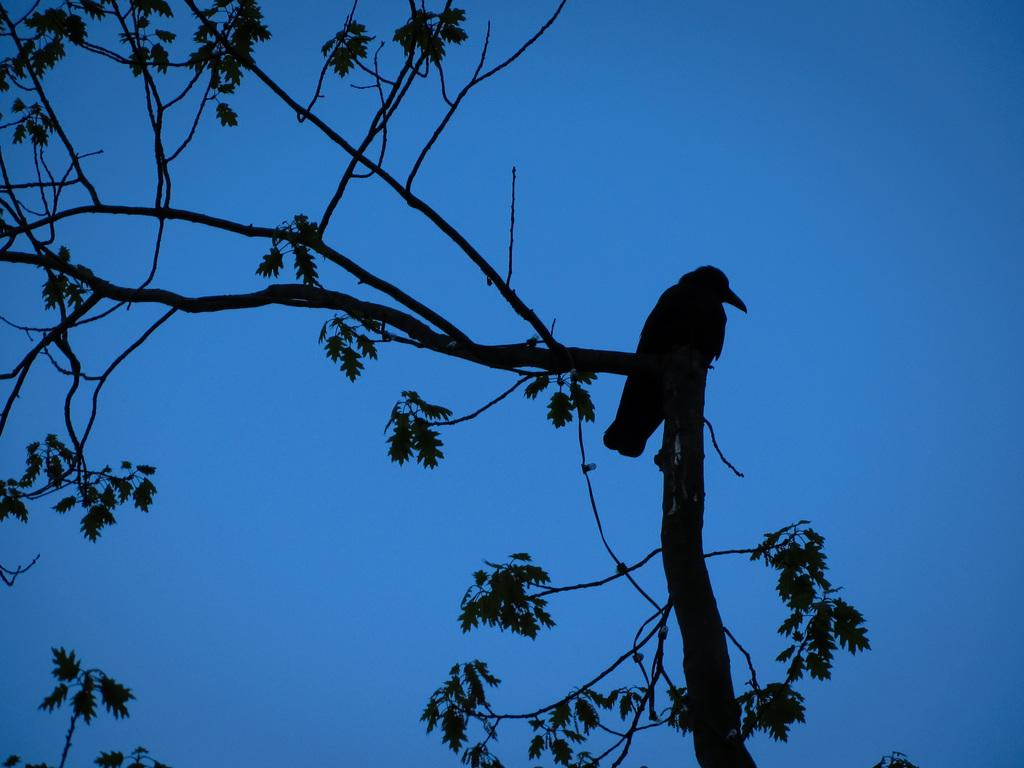What type of animal is in the image? There is a bird in the image. Where is the bird located? The bird is standing on a branch. What is the branch a part of? The branch is part of a tree. What type of bells can be heard ringing in the image? There are no bells present in the image, and therefore no ringing can be heard. 